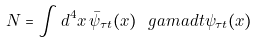<formula> <loc_0><loc_0><loc_500><loc_500>N = \int d ^ { 4 } x \, \bar { \psi } _ { \tau t } ( x ) \ g a m a d t \psi _ { \tau t } ( x )</formula> 